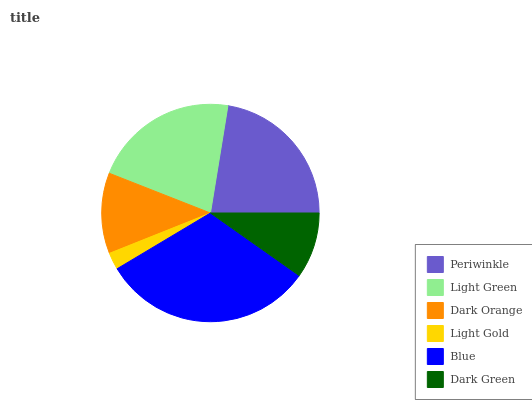Is Light Gold the minimum?
Answer yes or no. Yes. Is Blue the maximum?
Answer yes or no. Yes. Is Light Green the minimum?
Answer yes or no. No. Is Light Green the maximum?
Answer yes or no. No. Is Periwinkle greater than Light Green?
Answer yes or no. Yes. Is Light Green less than Periwinkle?
Answer yes or no. Yes. Is Light Green greater than Periwinkle?
Answer yes or no. No. Is Periwinkle less than Light Green?
Answer yes or no. No. Is Light Green the high median?
Answer yes or no. Yes. Is Dark Orange the low median?
Answer yes or no. Yes. Is Blue the high median?
Answer yes or no. No. Is Light Gold the low median?
Answer yes or no. No. 